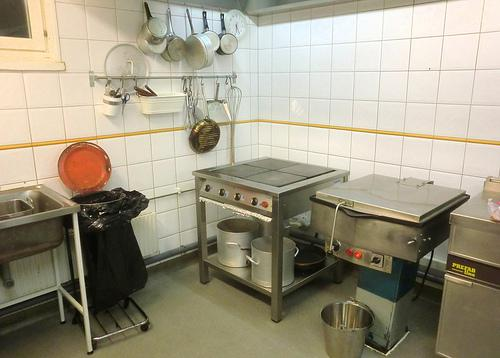Question: where is this scene?
Choices:
A. In the restaurant.
B. In the kitchen.
C. In the bedroom.
D. In the bathroom.
Answer with the letter. Answer: B Question: what color is the wall?
Choices:
A. Beige.
B. Yellow.
C. Blue.
D. White.
Answer with the letter. Answer: D Question: who is in the photo?
Choices:
A. A boy.
B. Nobody.
C. A girl.
D. A man.
Answer with the letter. Answer: B 